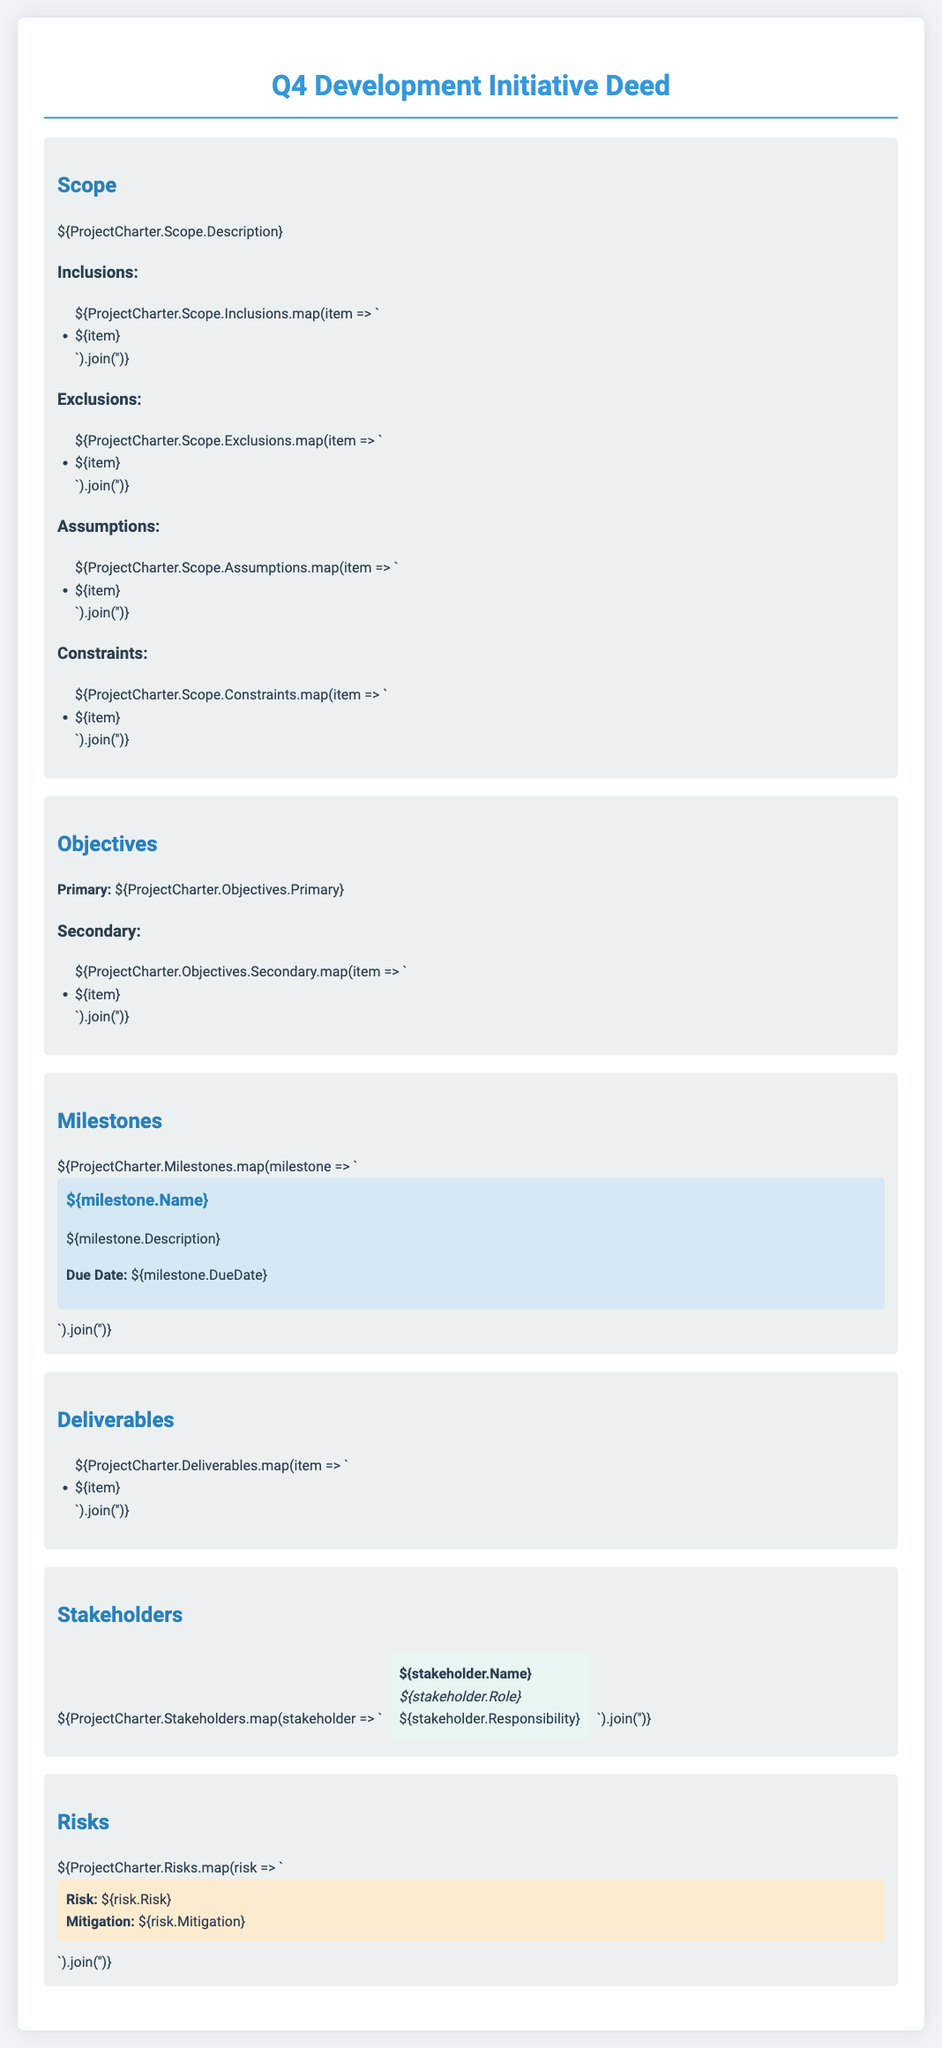What is the primary objective of the initiative? The primary objective is clearly stated in the Objectives section of the document.
Answer: ${ProjectCharter.Objectives.Primary} What is the due date of the first milestone? Each milestone includes a due date, which can be found in the Milestones section.
Answer: ${ProjectCharter.Milestones[0].DueDate} What is the description of the project scope? The scope description provides an overview of the project's boundaries and context.
Answer: ${ProjectCharter.Scope.Description} How many secondary objectives are listed? The number of secondary objectives can be counted from the list in the Objectives section.
Answer: ${ProjectCharter.Objectives.Secondary.length} Which stakeholder has the role of project sponsor? The role of project sponsor can be identified in the Stakeholders section.
Answer: ${ProjectCharter.Stakeholders.find(stakeholder => stakeholder.Role === "Project Sponsor").Name} What is one assumption mentioned in the scope? The assumptions section lists specific conditions accepted for the project.
Answer: ${ProjectCharter.Scope.Assumptions[0]} What color is used for the risk boxes? The risk section has a specific background color that helps differentiate it from other sections.
Answer: Light yellow List one deliverable of the project. The Deliverables section contains items that are expected to be produced during the project.
Answer: ${ProjectCharter.Deliverables[0]} 